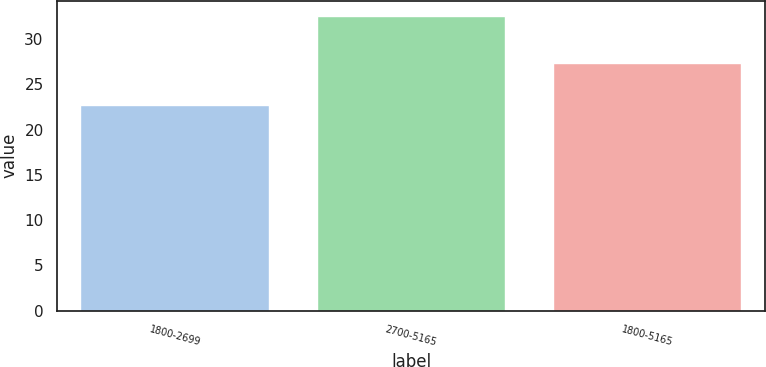Convert chart. <chart><loc_0><loc_0><loc_500><loc_500><bar_chart><fcel>1800-2699<fcel>2700-5165<fcel>1800-5165<nl><fcel>22.75<fcel>32.58<fcel>27.34<nl></chart> 